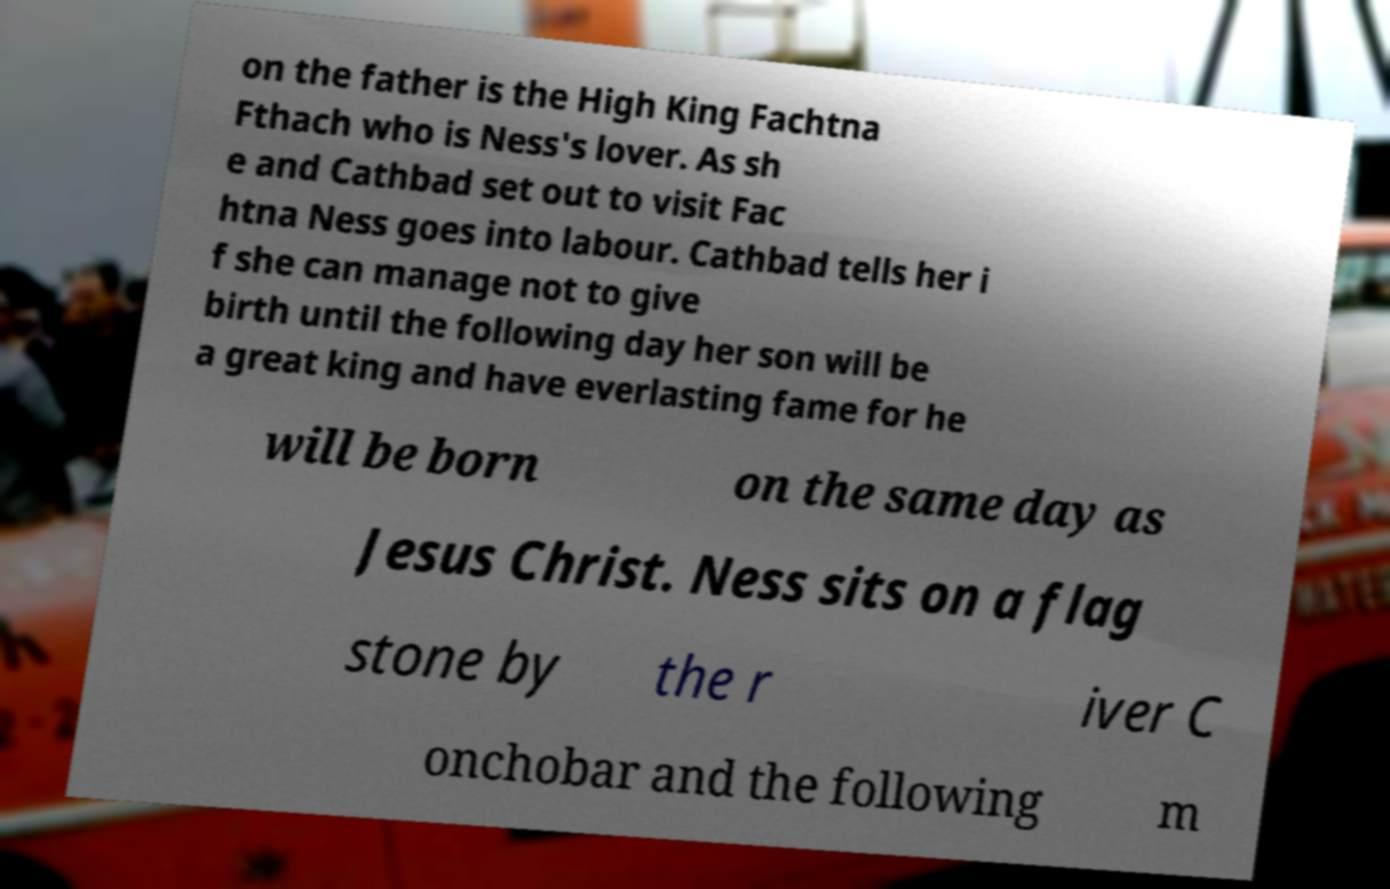Could you assist in decoding the text presented in this image and type it out clearly? on the father is the High King Fachtna Fthach who is Ness's lover. As sh e and Cathbad set out to visit Fac htna Ness goes into labour. Cathbad tells her i f she can manage not to give birth until the following day her son will be a great king and have everlasting fame for he will be born on the same day as Jesus Christ. Ness sits on a flag stone by the r iver C onchobar and the following m 